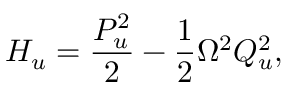Convert formula to latex. <formula><loc_0><loc_0><loc_500><loc_500>H _ { u } = \frac { P _ { u } ^ { 2 } } { 2 } - \frac { 1 } { 2 } \Omega ^ { 2 } Q _ { u } ^ { 2 } ,</formula> 